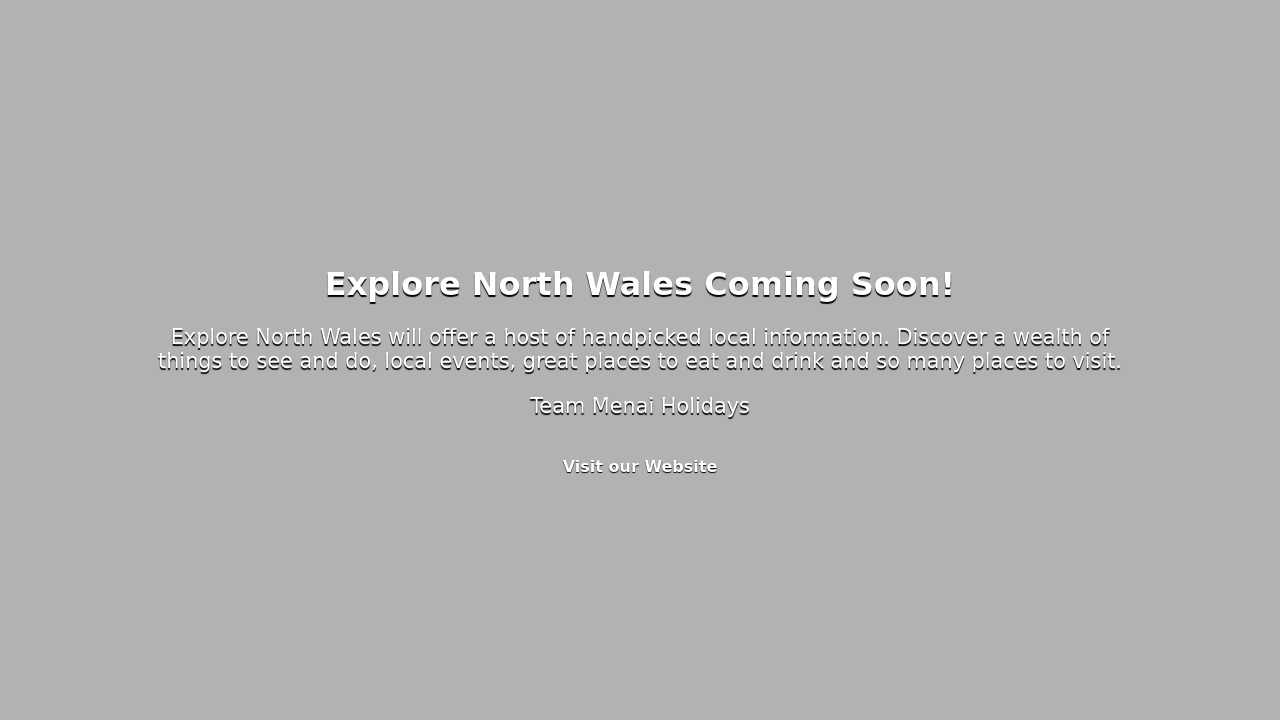What's the procedure for constructing this website from scratch with HTML? To construct a website from scratch, start by planning your design and content. Write the HTML code to structure your website, including elements like headers, paragraphs, links, and images. Apply CSS to style these elements, such as setting fonts, colors, and layout properties. For a 'coming soon' page, you would typically include a main headline, a brief description, and a link or form for visitors to stay informed. After designing and implementing the HTML and CSS, test your website across different browsers and devices to ensure compatibility and responsiveness. Finally, deploy your website to a web server and it will be accessible on the internet. Remember that building an effective website also involves optimization for search engines and ensuring accessibility standards are met. 